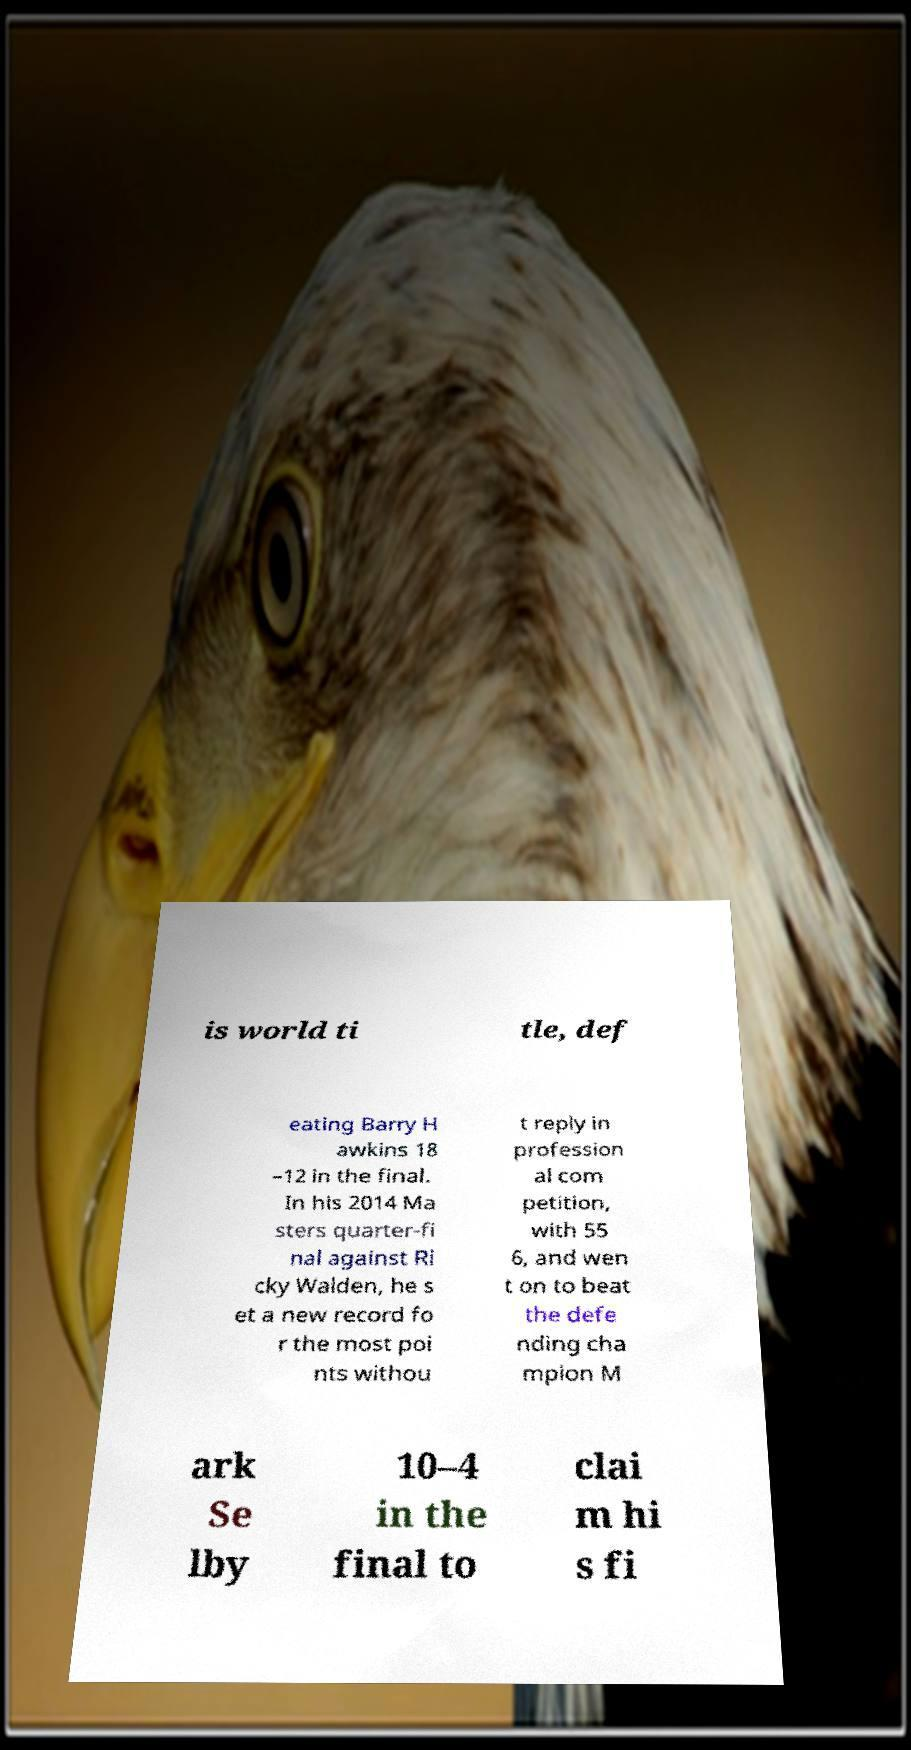Can you read and provide the text displayed in the image?This photo seems to have some interesting text. Can you extract and type it out for me? is world ti tle, def eating Barry H awkins 18 –12 in the final. In his 2014 Ma sters quarter-fi nal against Ri cky Walden, he s et a new record fo r the most poi nts withou t reply in profession al com petition, with 55 6, and wen t on to beat the defe nding cha mpion M ark Se lby 10–4 in the final to clai m hi s fi 